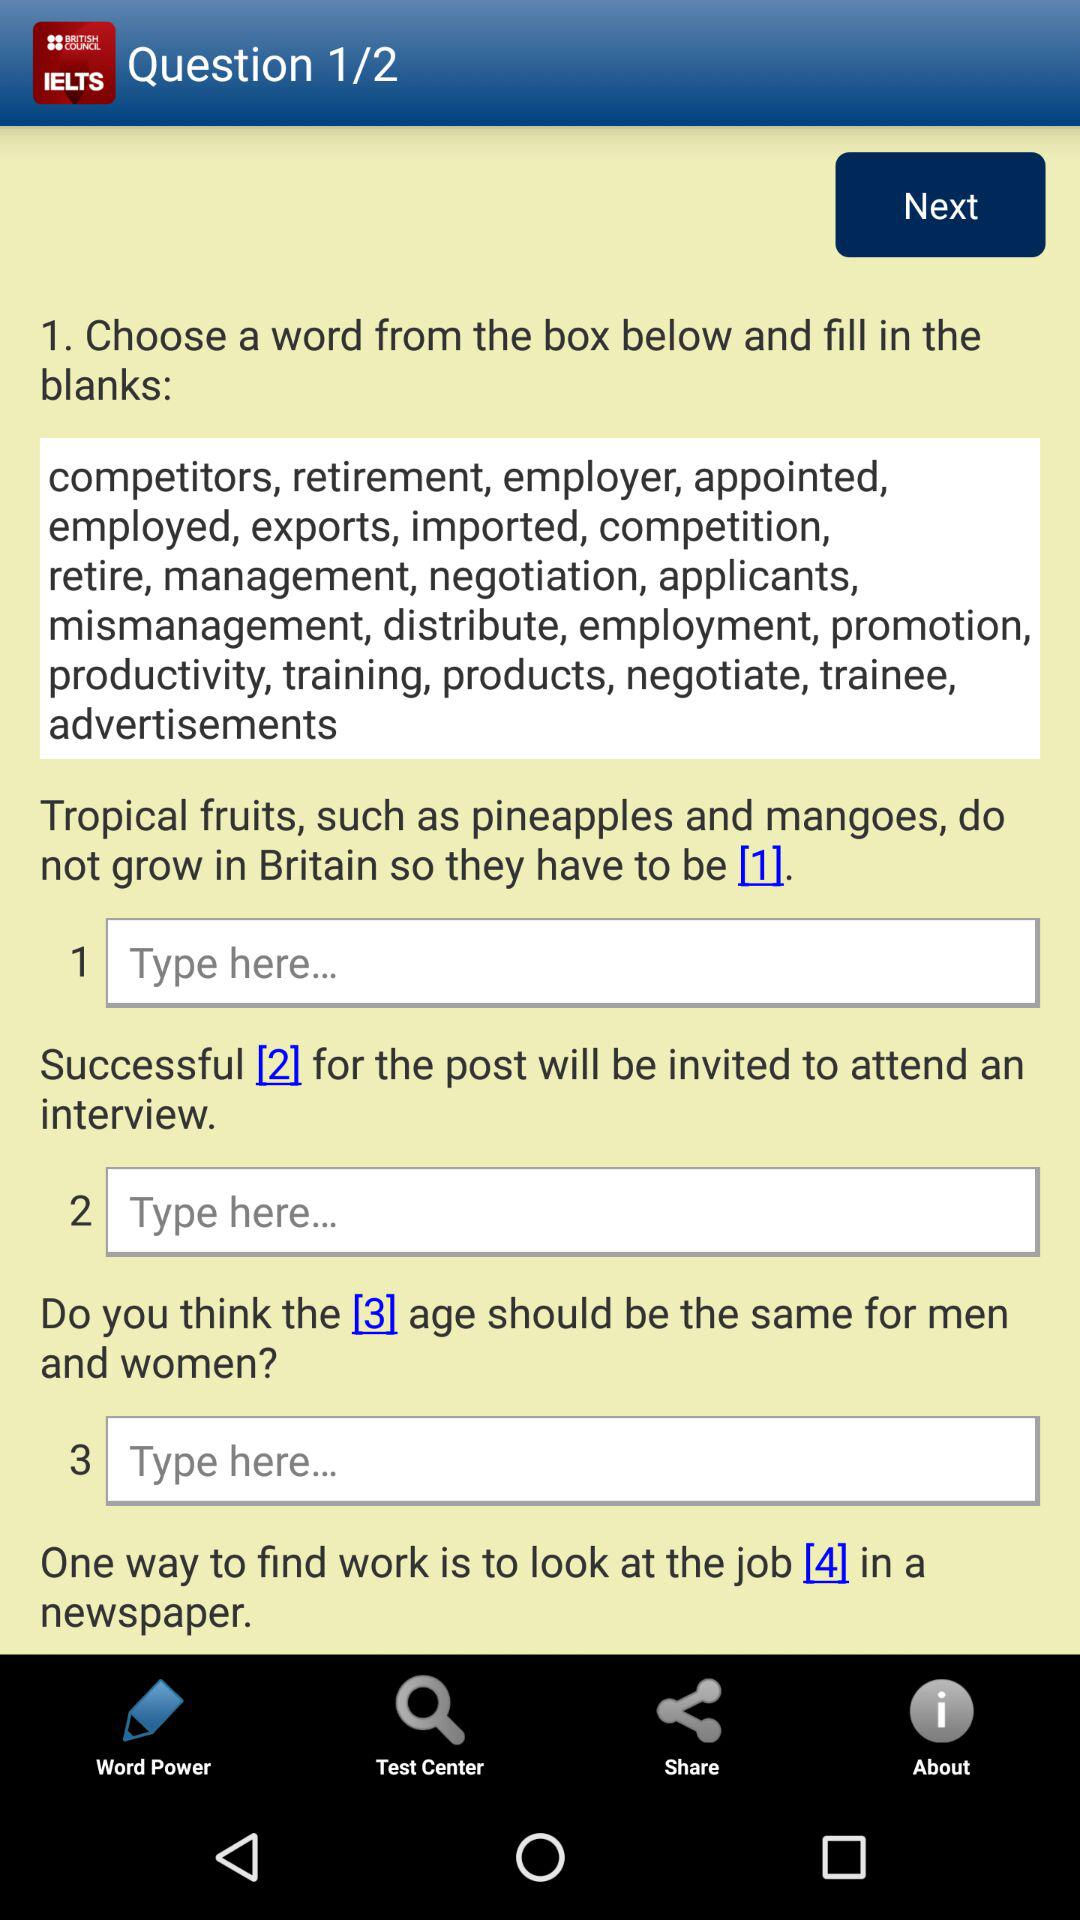Which option is selected in the taskbar? The selected option in the task bar is "Word Power". 